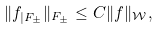Convert formula to latex. <formula><loc_0><loc_0><loc_500><loc_500>\| f _ { | F _ { \pm } } \| _ { F _ { \pm } } \leq C \| f \| _ { \mathcal { W } } ,</formula> 